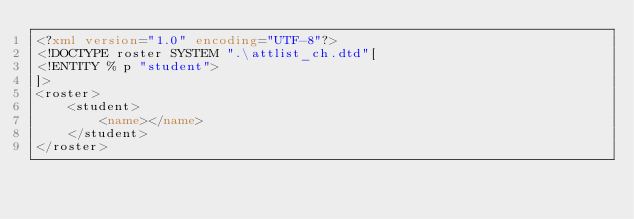<code> <loc_0><loc_0><loc_500><loc_500><_XML_><?xml version="1.0" encoding="UTF-8"?>
<!DOCTYPE roster SYSTEM ".\attlist_ch.dtd"[
<!ENTITY % p "student">
]>
<roster>
	<student>
		<name></name>
	</student>
</roster>
</code> 